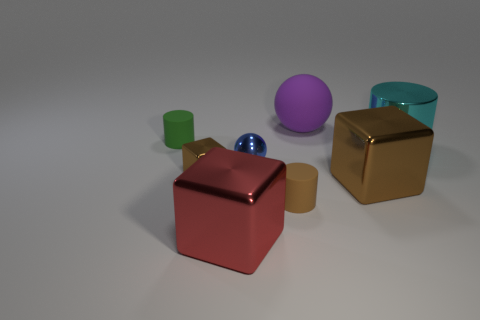What size is the metal block that is on the right side of the small matte cylinder on the right side of the tiny brown metal thing?
Keep it short and to the point. Large. What number of brown rubber objects have the same size as the purple matte object?
Offer a terse response. 0. There is a big block behind the brown cylinder; is its color the same as the sphere behind the tiny metal ball?
Keep it short and to the point. No. There is a cyan cylinder; are there any large brown cubes behind it?
Offer a very short reply. No. What is the color of the big object that is on the right side of the blue metallic thing and in front of the cyan shiny object?
Offer a very short reply. Brown. Are there any tiny shiny objects that have the same color as the shiny sphere?
Your answer should be compact. No. Are the small thing behind the big metallic cylinder and the ball in front of the green object made of the same material?
Ensure brevity in your answer.  No. There is a brown metallic block right of the tiny shiny ball; what is its size?
Your answer should be very brief. Large. The purple thing is what size?
Keep it short and to the point. Large. How big is the brown metal block that is to the left of the metallic thing in front of the brown matte cylinder to the right of the large red metal thing?
Your answer should be compact. Small. 